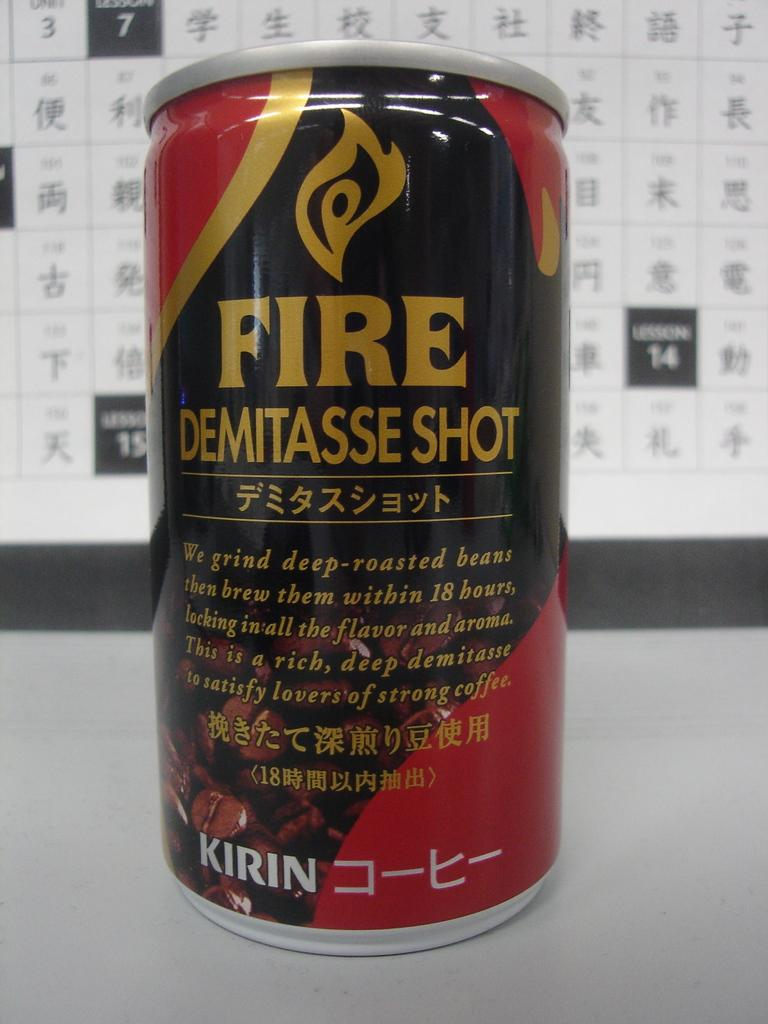<image>
Create a compact narrative representing the image presented. The beverage tin shown advertised Fire Demitasse Shot. 